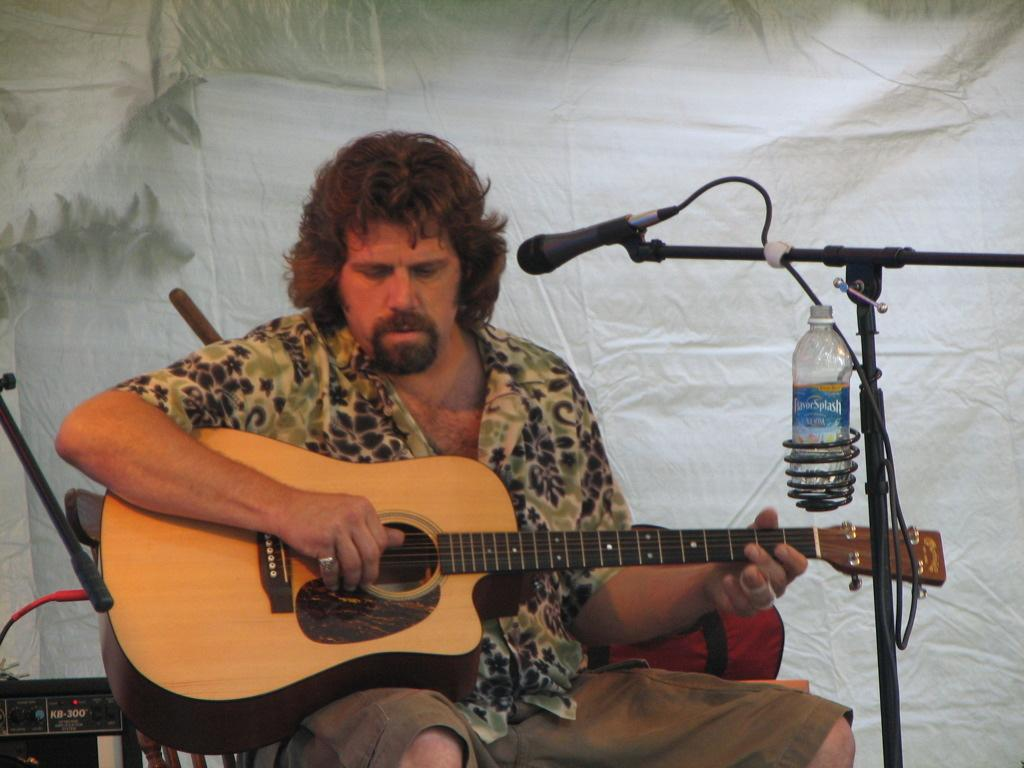What is the man in the image doing? The man is sitting and playing a guitar in the image. What object is present near the man? There is a microphone in the bottom right corner of the image. What can be seen in the background of the image? There is a curtain at the top of the image. What other item is visible in the image? There is a bottle in the image. What type of silverware is visible in the image? There is no silverware present in the image. 